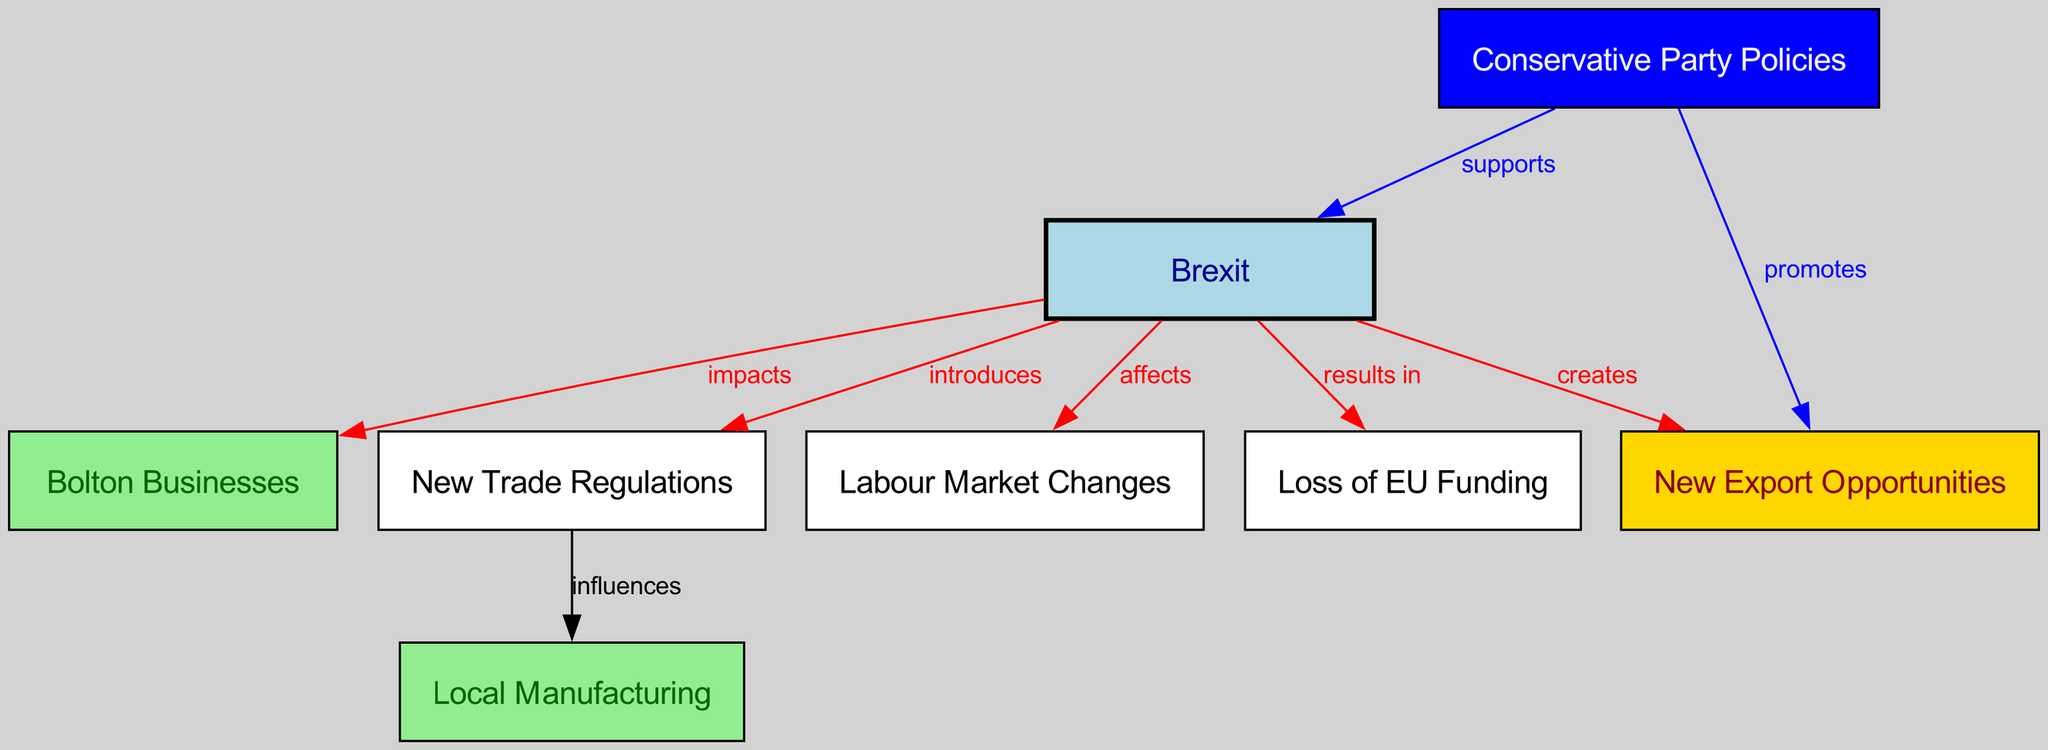What are the main impacts of Brexit on local businesses? The diagram shows a direct relationship from Brexit to Bolton Businesses, indicating that Brexit has several implications for them.
Answer: impacts How many nodes are there in the diagram? Counting the nodes listed in the data section, there are a total of 8 nodes representing various concepts related to Brexit and Bolton Businesses.
Answer: 8 What relationship exists between Brexit and new trade regulations? The diagram indicates that Brexit introduces new trade regulations, establishing a clear causal link between the two concepts.
Answer: introduces What does Brexit create for Bolton businesses? The diagram shows that Brexit creates new export opportunities for Bolton businesses, suggesting a beneficial effect in that area.
Answer: new export opportunities How does the Conservative Party relate to Brexit? The diagram indicates that the Conservative Party supports Brexit, establishing a supportive relationship between these two nodes.
Answer: supports What effect does Brexit have on the labour market? According to the diagram, Brexit affects the labour market, showing a direct relationship that suggests changes will occur in employment dynamics.
Answer: affects What influences local manufacturing according to the diagram? The diagram indicates that new trade regulations influence local manufacturing, meaning that changes in regulations can have a direct impact on manufacturing processes in Bolton.
Answer: influences How does the Conservative Party promote export opportunities? The diagram indicates that the Conservative Party promotes export opportunities, showcasing its role in enhancing such opportunities for local businesses post-Brexit.
Answer: promotes What is the outcome of Brexit related to EU funding? The diagram states that Brexit results in a loss of EU funding, indicating the negative financial impact on local businesses due to the change in funding sources.
Answer: loss of EU funding 